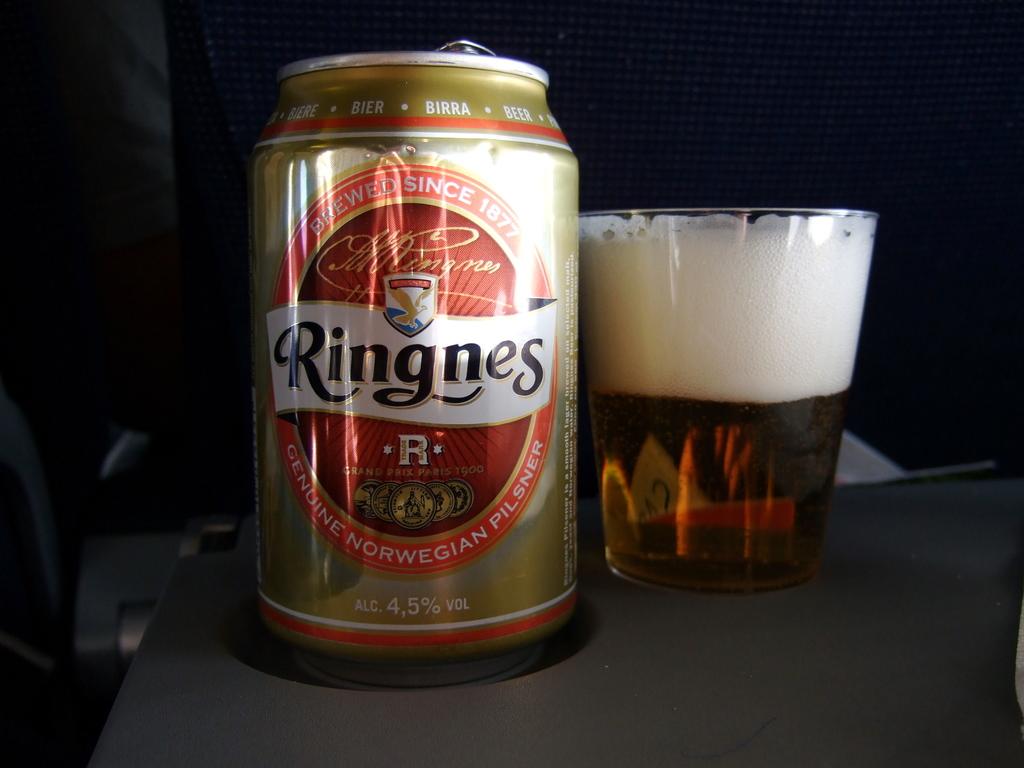Is this norwegian?
Your answer should be very brief. Yes. What is the name of the drink?
Offer a very short reply. Ringnes. 